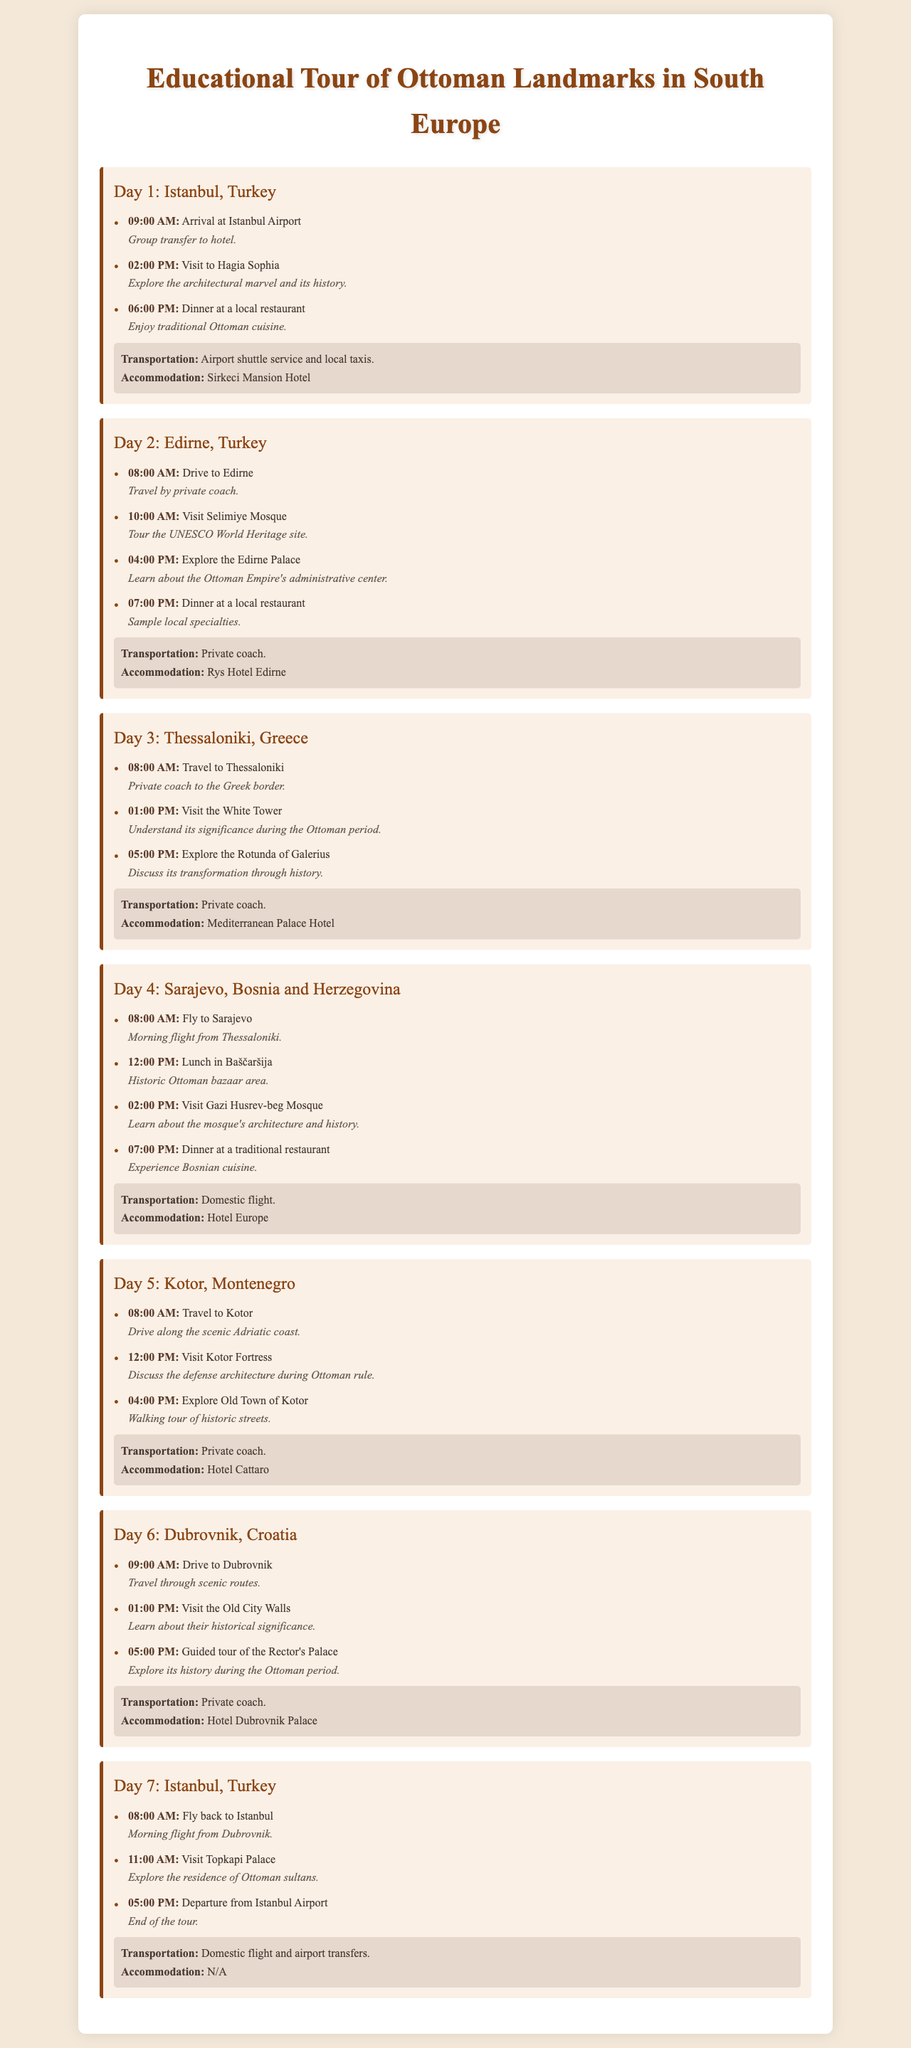What is the title of the itinerary? The title is clearly stated at the top of the document which is "Educational Tour of Ottoman Landmarks in South Europe."
Answer: Educational Tour of Ottoman Landmarks in South Europe How many days does the tour last? The document outlines the itinerary over a series of days, specifically detailing activities for 7 different days.
Answer: 7 What is the accommodation for Day 4? The accommodation information is listed under each day section, for Day 4 it is "Hotel Europe."
Answer: Hotel Europe What time does the group arrive at Istanbul Airport on Day 1? The arrival time is specified in the activities for Day 1, which is at "09:00 AM."
Answer: 09:00 AM What is the transportation mode for Day 2? Each day's activities include a section on transportation, for Day 2, it mentions "Private coach."
Answer: Private coach What landmark is visited at 01:00 PM on Day 3? The itinerary specifies the visit to a particular landmark at this time on Day 3, which is the "White Tower."
Answer: White Tower What specialty type of cuisine is served during the dinners? The dinners on various days highlight local culinary offerings, specifically mentioning "traditional Ottoman cuisine."
Answer: Traditional Ottoman cuisine What city is visited on Day 5? The document lists cities for each day, and Day 5 specifically mentions "Kotor."
Answer: Kotor What is the departure activity on Day 7? The last day outlines the final activities, with the departure noted as occurring at "05:00 PM" with a mention of the airport.
Answer: Departure from Istanbul Airport 